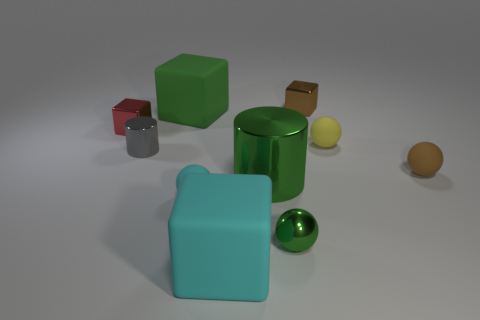What can the arrangement of objects tell us about spatial composition and balance in digital art? The distribution of objects in the image provides a harmonious spatial composition, with varying geometric forms and colors arranged to create a visually balanced scene. This digital art piece subtly emphasizes the interplay between symmetry and asymmetry, and encourages the viewer to reflect on the aesthetic choices made by the artist. 